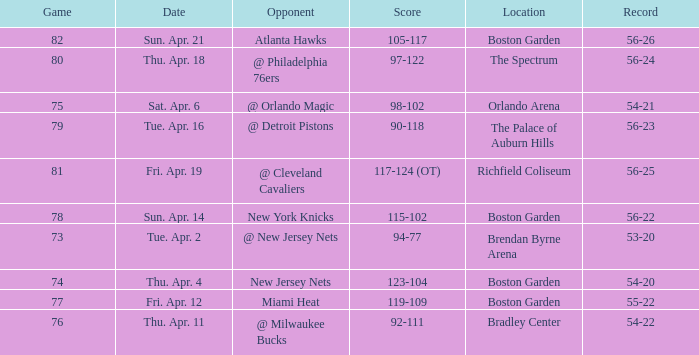Which Opponent has a Score of 92-111? @ Milwaukee Bucks. 